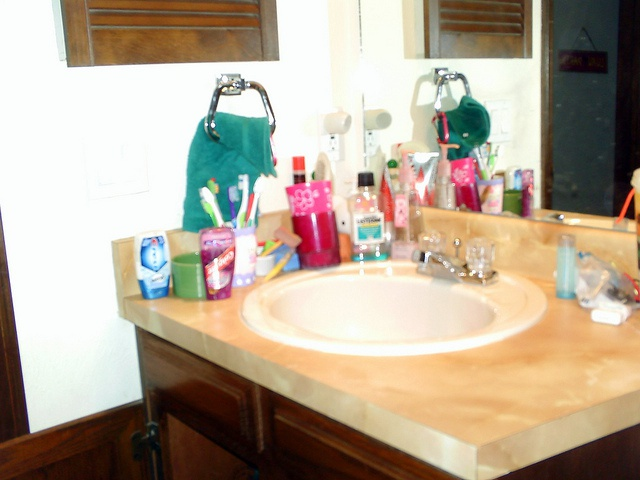Describe the objects in this image and their specific colors. I can see sink in white, ivory, tan, and darkgray tones, cup in white, violet, and brown tones, bottle in white, lightgray, lightpink, tan, and darkgray tones, bottle in white, lightblue, and blue tones, and cup in white, green, olive, and lightgreen tones in this image. 